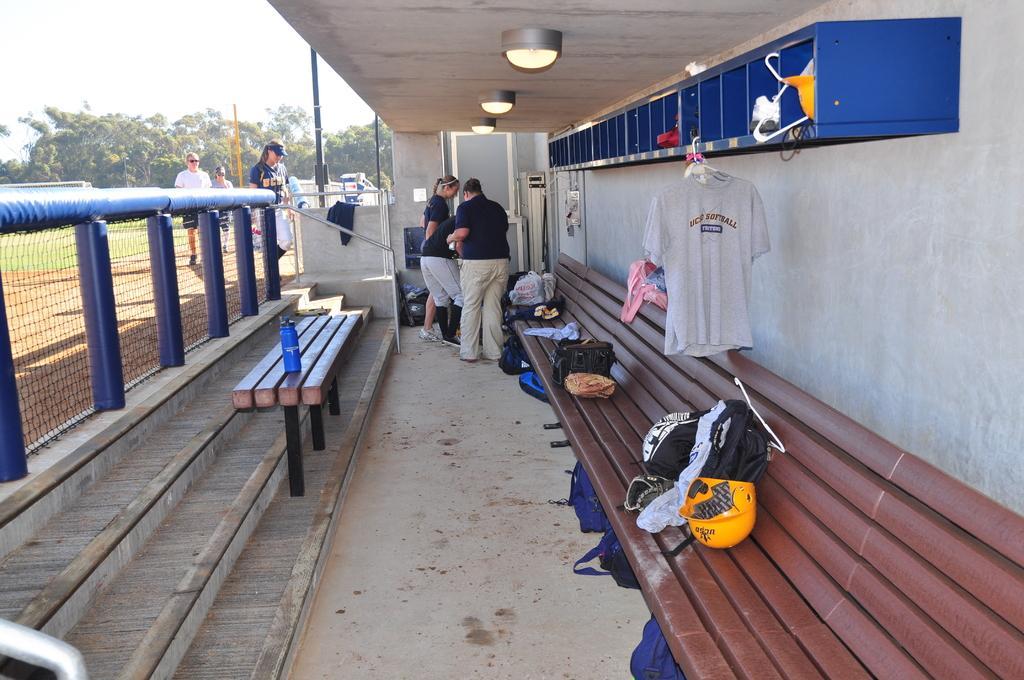How would you summarize this image in a sentence or two? This picture describes about group of people you can find helmet, baggage, bottle on the table and also we can find couple of lights and trees. 